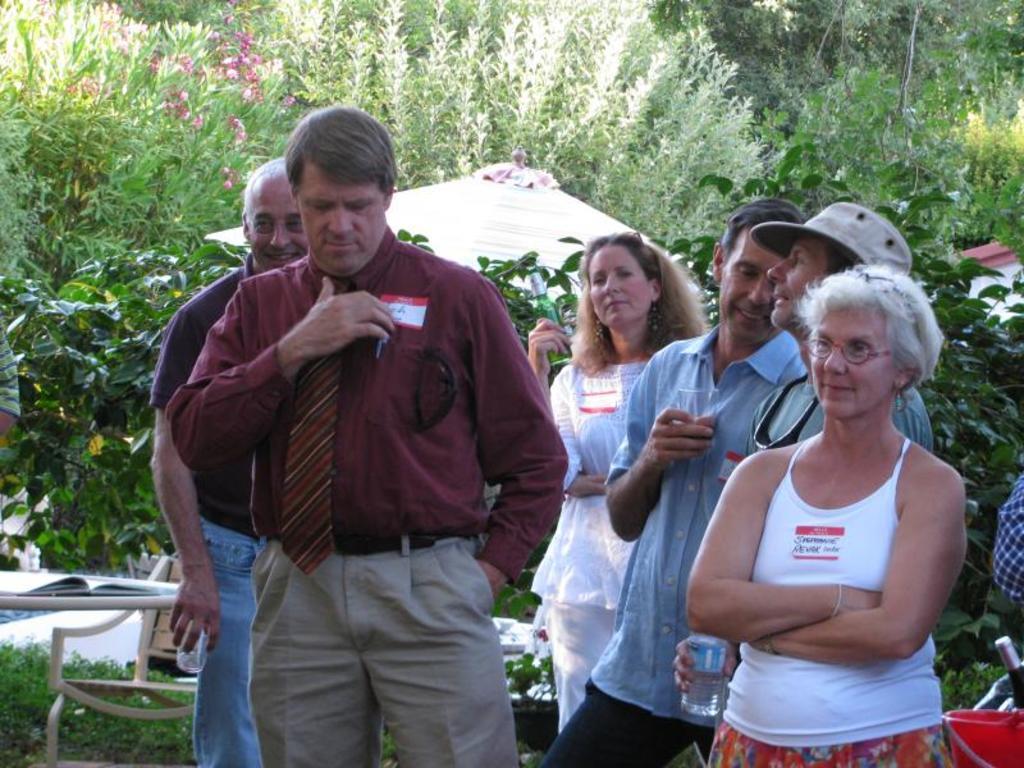How would you summarize this image in a sentence or two? In this picture we can see a group of people and in the background we can see trees. 